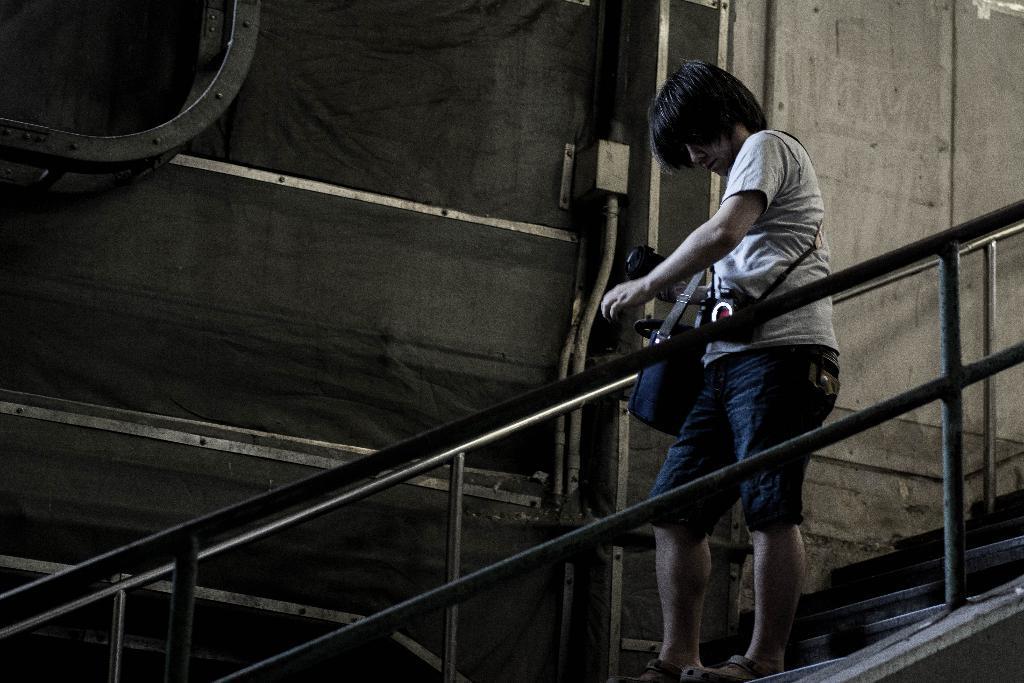Can you describe this image briefly? In this image there is a woman standing, she is wearing a bag, there are staircase, there is a wall, there is a metal object towards the top of the image, there is a metal object towards the bottom of the image. 